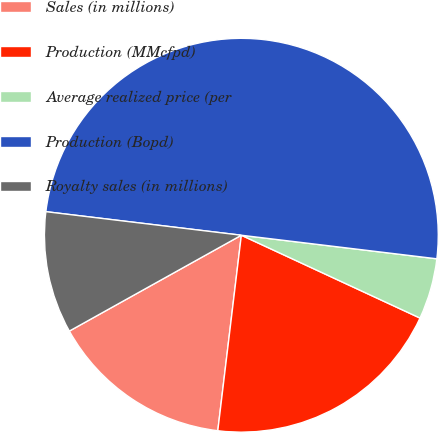Convert chart to OTSL. <chart><loc_0><loc_0><loc_500><loc_500><pie_chart><fcel>Sales (in millions)<fcel>Production (MMcfpd)<fcel>Average realized price (per<fcel>Production (Bopd)<fcel>Royalty sales (in millions)<nl><fcel>15.0%<fcel>20.0%<fcel>5.0%<fcel>50.0%<fcel>10.0%<nl></chart> 